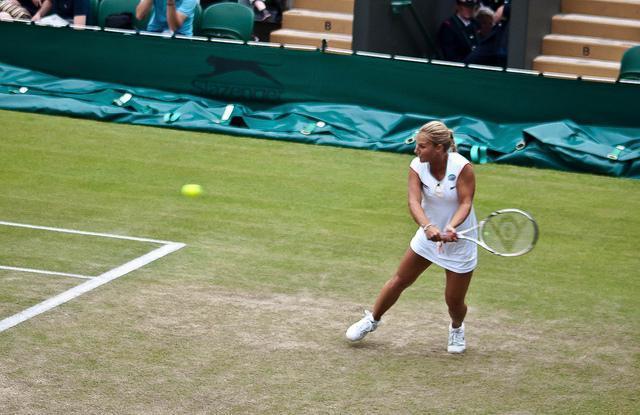How many people are there?
Give a very brief answer. 1. 